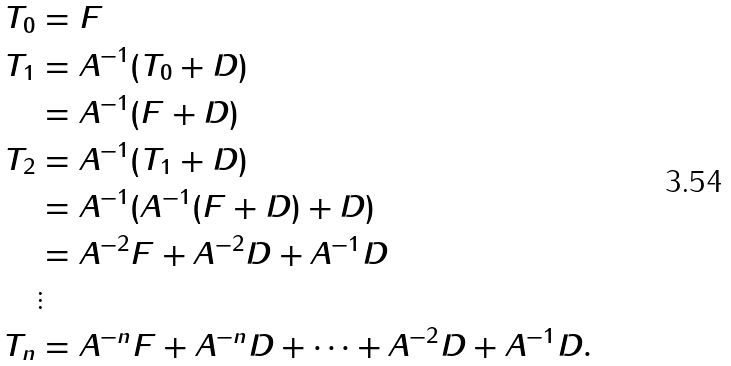Convert formula to latex. <formula><loc_0><loc_0><loc_500><loc_500>T _ { 0 } & = F \\ T _ { 1 } & = A ^ { - 1 } ( T _ { 0 } + D ) \\ & = A ^ { - 1 } ( F + D ) \\ T _ { 2 } & = A ^ { - 1 } ( T _ { 1 } + D ) \\ & = A ^ { - 1 } ( A ^ { - 1 } ( F + D ) + D ) \\ & = A ^ { - 2 } F + A ^ { - 2 } D + A ^ { - 1 } D \\ & \vdots \\ T _ { n } & = A ^ { - n } F + A ^ { - n } D + \cdots + A ^ { - 2 } D + A ^ { - 1 } D .</formula> 